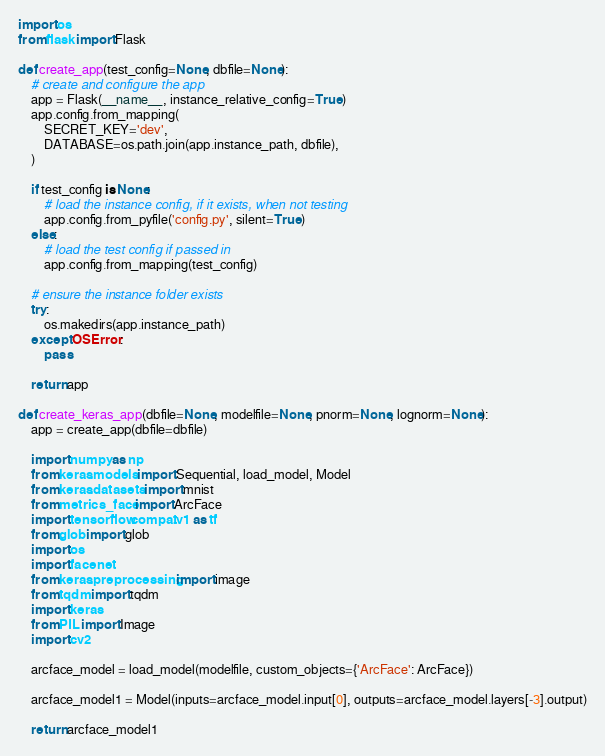Convert code to text. <code><loc_0><loc_0><loc_500><loc_500><_Python_>import os
from flask import Flask

def create_app(test_config=None, dbfile=None):
    # create and configure the app
    app = Flask(__name__, instance_relative_config=True)
    app.config.from_mapping(
        SECRET_KEY='dev',
        DATABASE=os.path.join(app.instance_path, dbfile),
    )

    if test_config is None:
        # load the instance config, if it exists, when not testing
        app.config.from_pyfile('config.py', silent=True)
    else:
        # load the test config if passed in
        app.config.from_mapping(test_config)

    # ensure the instance folder exists
    try:
        os.makedirs(app.instance_path)
    except OSError:
        pass

    return app

def create_keras_app(dbfile=None, modelfile=None, pnorm=None, lognorm=None):
    app = create_app(dbfile=dbfile)

    import numpy as np
    from keras.models import Sequential, load_model, Model
    from keras.datasets import mnist
    from metrics_face import ArcFace
    import tensorflow.compat.v1 as tf
    from glob import glob
    import os
    import facenet
    from keras.preprocessing import image
    from tqdm import tqdm
    import keras
    from PIL import Image
    import cv2

    arcface_model = load_model(modelfile, custom_objects={'ArcFace': ArcFace})

    arcface_model1 = Model(inputs=arcface_model.input[0], outputs=arcface_model.layers[-3].output)
    
    return arcface_model1</code> 